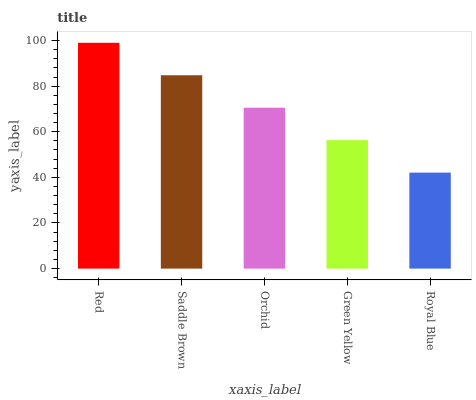Is Royal Blue the minimum?
Answer yes or no. Yes. Is Red the maximum?
Answer yes or no. Yes. Is Saddle Brown the minimum?
Answer yes or no. No. Is Saddle Brown the maximum?
Answer yes or no. No. Is Red greater than Saddle Brown?
Answer yes or no. Yes. Is Saddle Brown less than Red?
Answer yes or no. Yes. Is Saddle Brown greater than Red?
Answer yes or no. No. Is Red less than Saddle Brown?
Answer yes or no. No. Is Orchid the high median?
Answer yes or no. Yes. Is Orchid the low median?
Answer yes or no. Yes. Is Red the high median?
Answer yes or no. No. Is Red the low median?
Answer yes or no. No. 